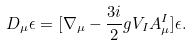Convert formula to latex. <formula><loc_0><loc_0><loc_500><loc_500>D _ { \mu } \epsilon = [ \nabla _ { \mu } - \frac { 3 i } { 2 } g V _ { I } A _ { \mu } ^ { I } ] \epsilon .</formula> 